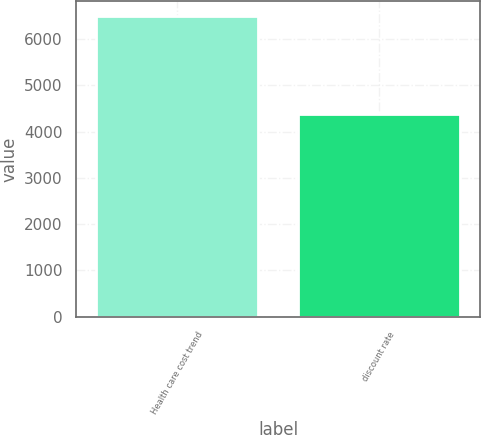<chart> <loc_0><loc_0><loc_500><loc_500><bar_chart><fcel>Health care cost trend<fcel>discount rate<nl><fcel>6500<fcel>4375<nl></chart> 